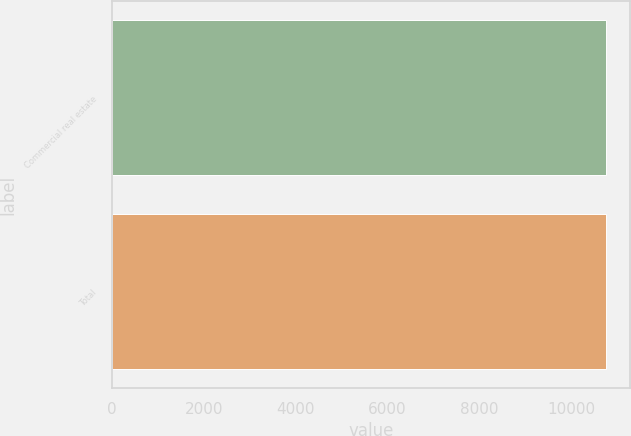<chart> <loc_0><loc_0><loc_500><loc_500><bar_chart><fcel>Commercial real estate<fcel>Total<nl><fcel>10750<fcel>10750.1<nl></chart> 